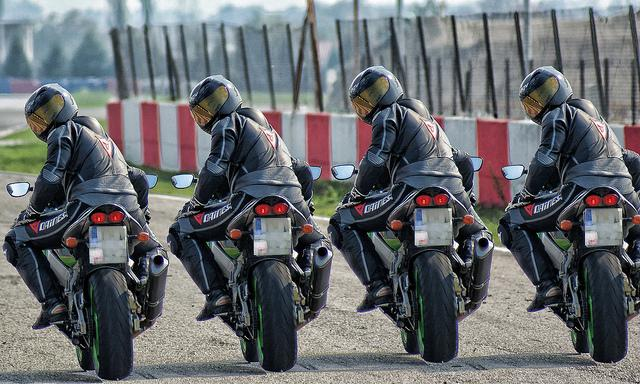What are the motorcycles riding on? Please explain your reasoning. asphalt. There is multiple of the same person on a motorcycle. it is a dark surface on a track. 